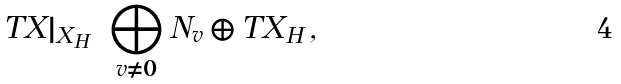Convert formula to latex. <formula><loc_0><loc_0><loc_500><loc_500>T X | _ { X _ { H } } = \bigoplus _ { v \neq 0 } N _ { v } \oplus T X _ { H } \, ,</formula> 